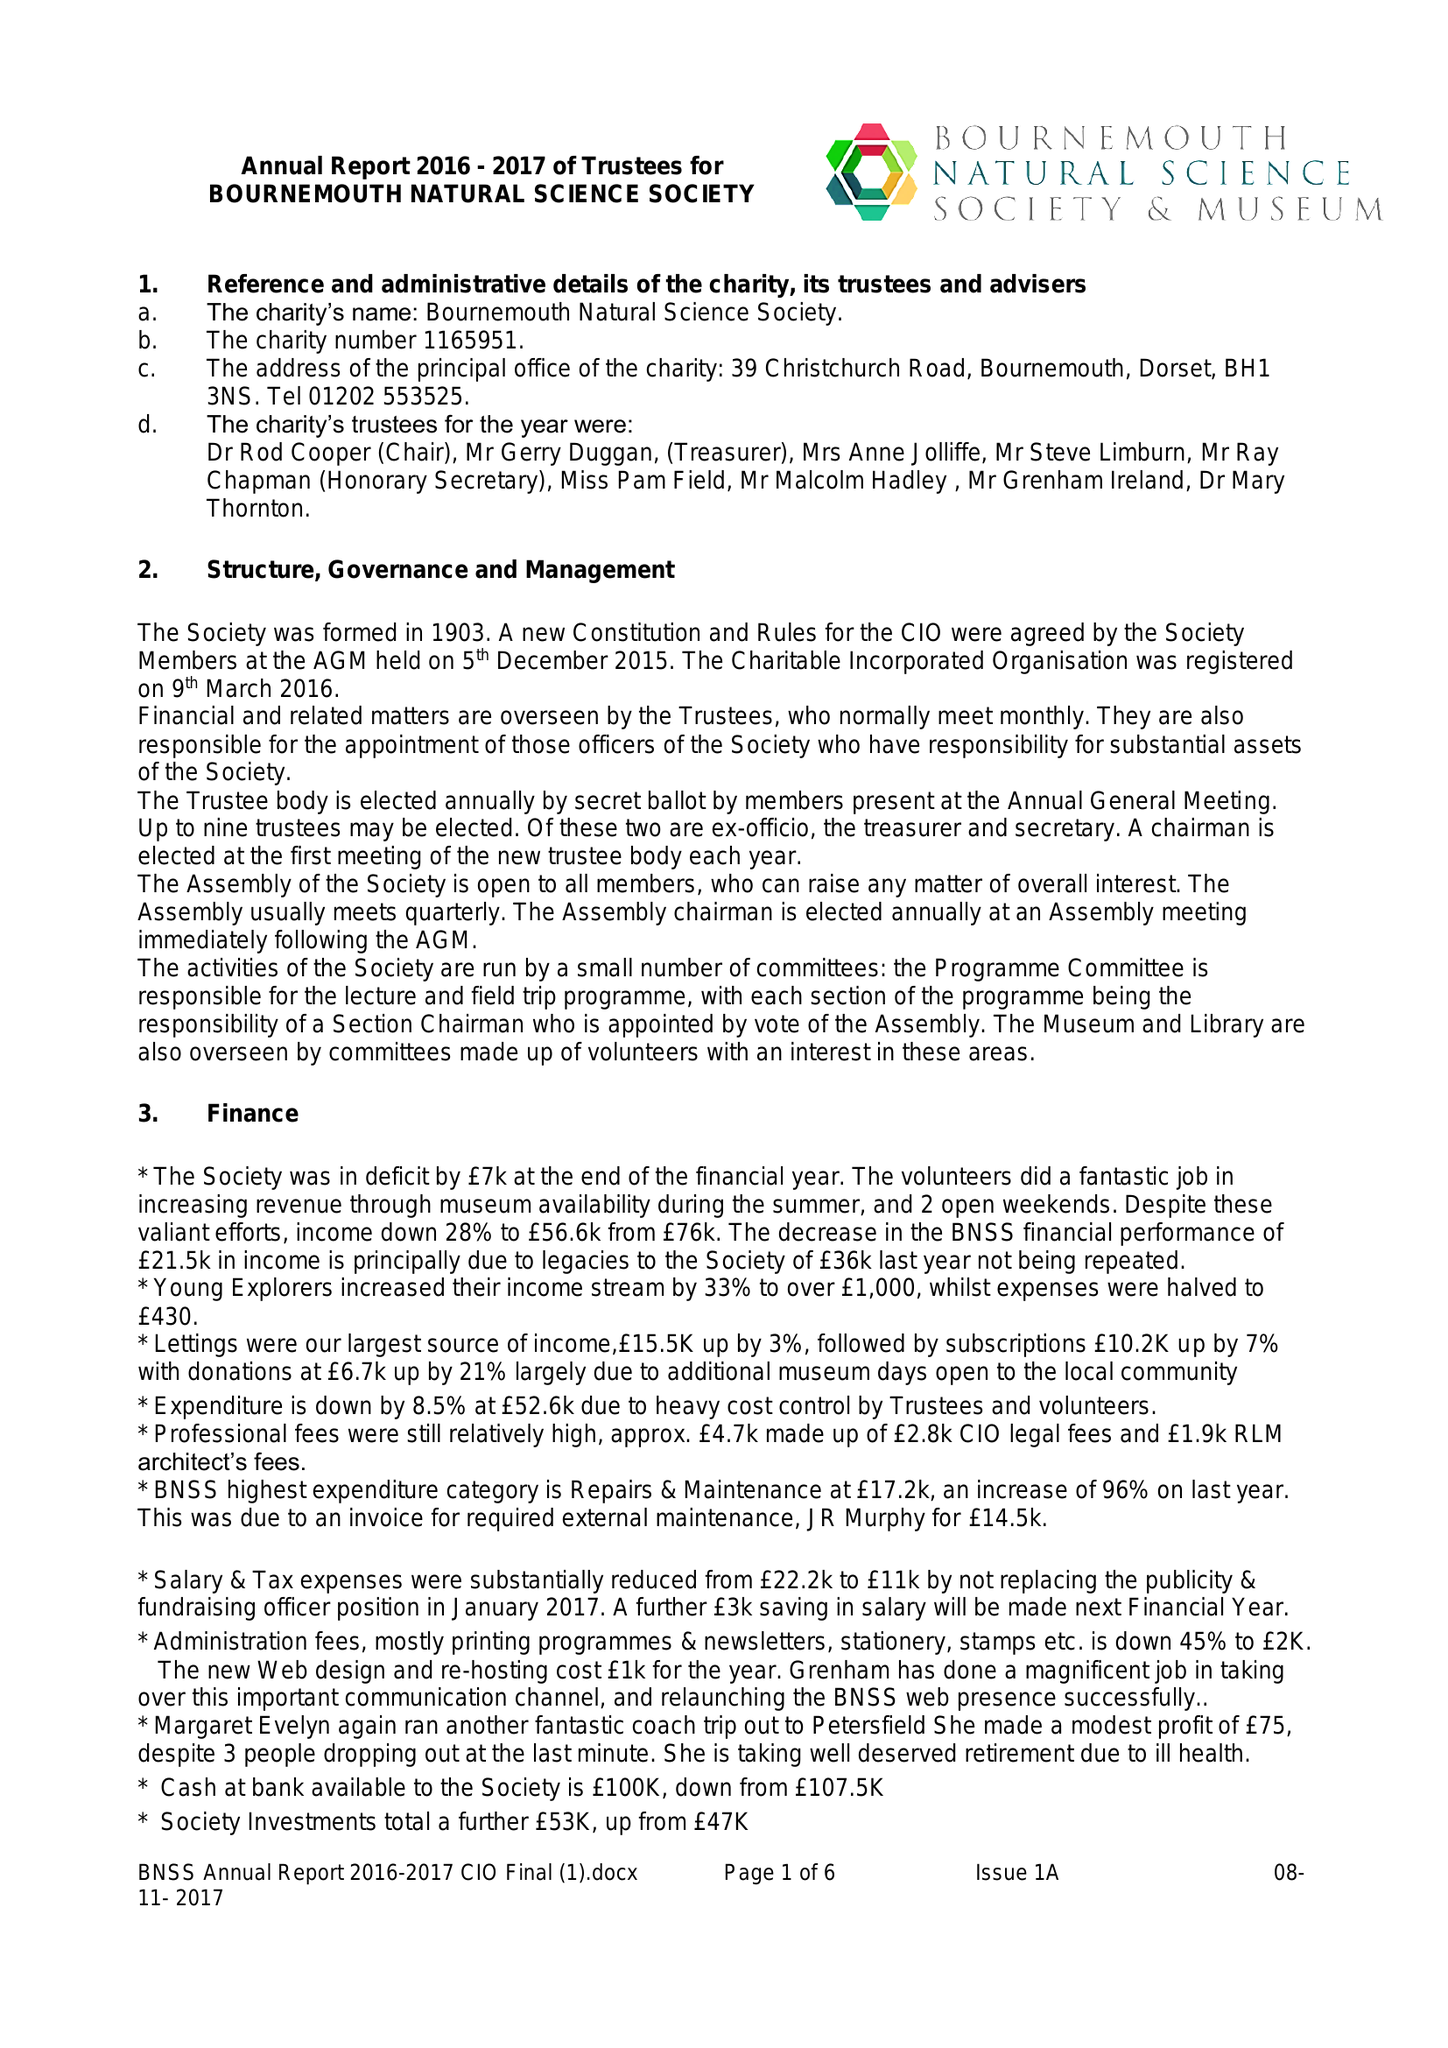What is the value for the address__street_line?
Answer the question using a single word or phrase. 39 CHRISTCHURCH ROAD 